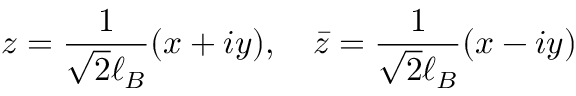<formula> <loc_0><loc_0><loc_500><loc_500>z = \frac { 1 } { \sqrt { 2 } \ell _ { B } } ( x + i y ) , \quad \bar { z } = \frac { 1 } { \sqrt { 2 } \ell _ { B } } ( x - i y )</formula> 